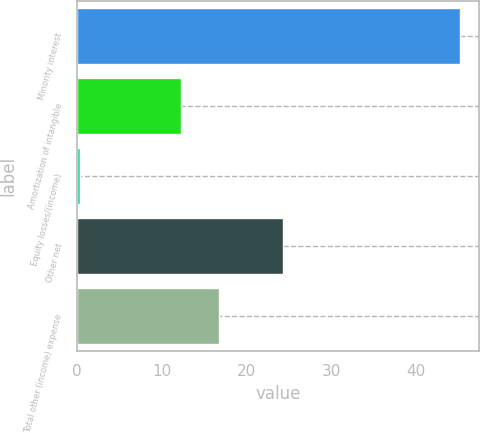Convert chart to OTSL. <chart><loc_0><loc_0><loc_500><loc_500><bar_chart><fcel>Minority interest<fcel>Amortization of intangible<fcel>Equity losses/(income)<fcel>Other net<fcel>Total other (income) expense<nl><fcel>45.2<fcel>12.3<fcel>0.3<fcel>24.3<fcel>16.79<nl></chart> 